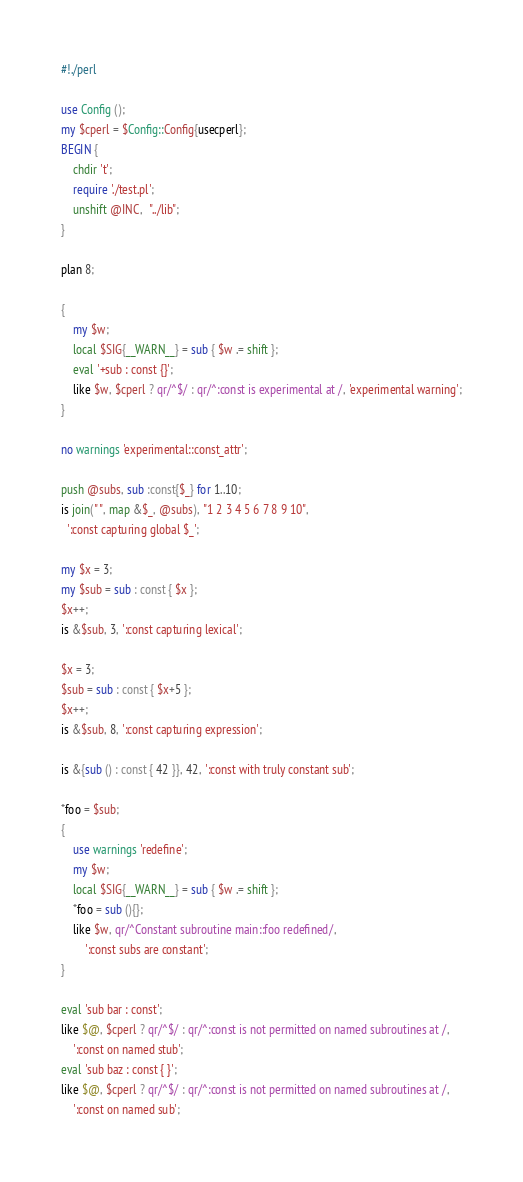Convert code to text. <code><loc_0><loc_0><loc_500><loc_500><_Perl_>#!./perl

use Config ();
my $cperl = $Config::Config{usecperl};
BEGIN {
    chdir 't';
    require './test.pl';
    unshift @INC,  "../lib";
}

plan 8;

{
    my $w;
    local $SIG{__WARN__} = sub { $w .= shift };
    eval '+sub : const {}';
    like $w, $cperl ? qr/^$/ : qr/^:const is experimental at /, 'experimental warning';
}

no warnings 'experimental::const_attr';

push @subs, sub :const{$_} for 1..10;
is join(" ", map &$_, @subs), "1 2 3 4 5 6 7 8 9 10",
  ':const capturing global $_';

my $x = 3;
my $sub = sub : const { $x };
$x++;
is &$sub, 3, ':const capturing lexical';

$x = 3;
$sub = sub : const { $x+5 };
$x++;
is &$sub, 8, ':const capturing expression';

is &{sub () : const { 42 }}, 42, ':const with truly constant sub';

*foo = $sub;
{
    use warnings 'redefine';
    my $w;
    local $SIG{__WARN__} = sub { $w .= shift };
    *foo = sub (){};
    like $w, qr/^Constant subroutine main::foo redefined/,
        ':const subs are constant';
}

eval 'sub bar : const';
like $@, $cperl ? qr/^$/ : qr/^:const is not permitted on named subroutines at /,
    ':const on named stub';
eval 'sub baz : const { }';
like $@, $cperl ? qr/^$/ : qr/^:const is not permitted on named subroutines at /,
    ':const on named sub';
</code> 